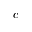Convert formula to latex. <formula><loc_0><loc_0><loc_500><loc_500>c</formula> 